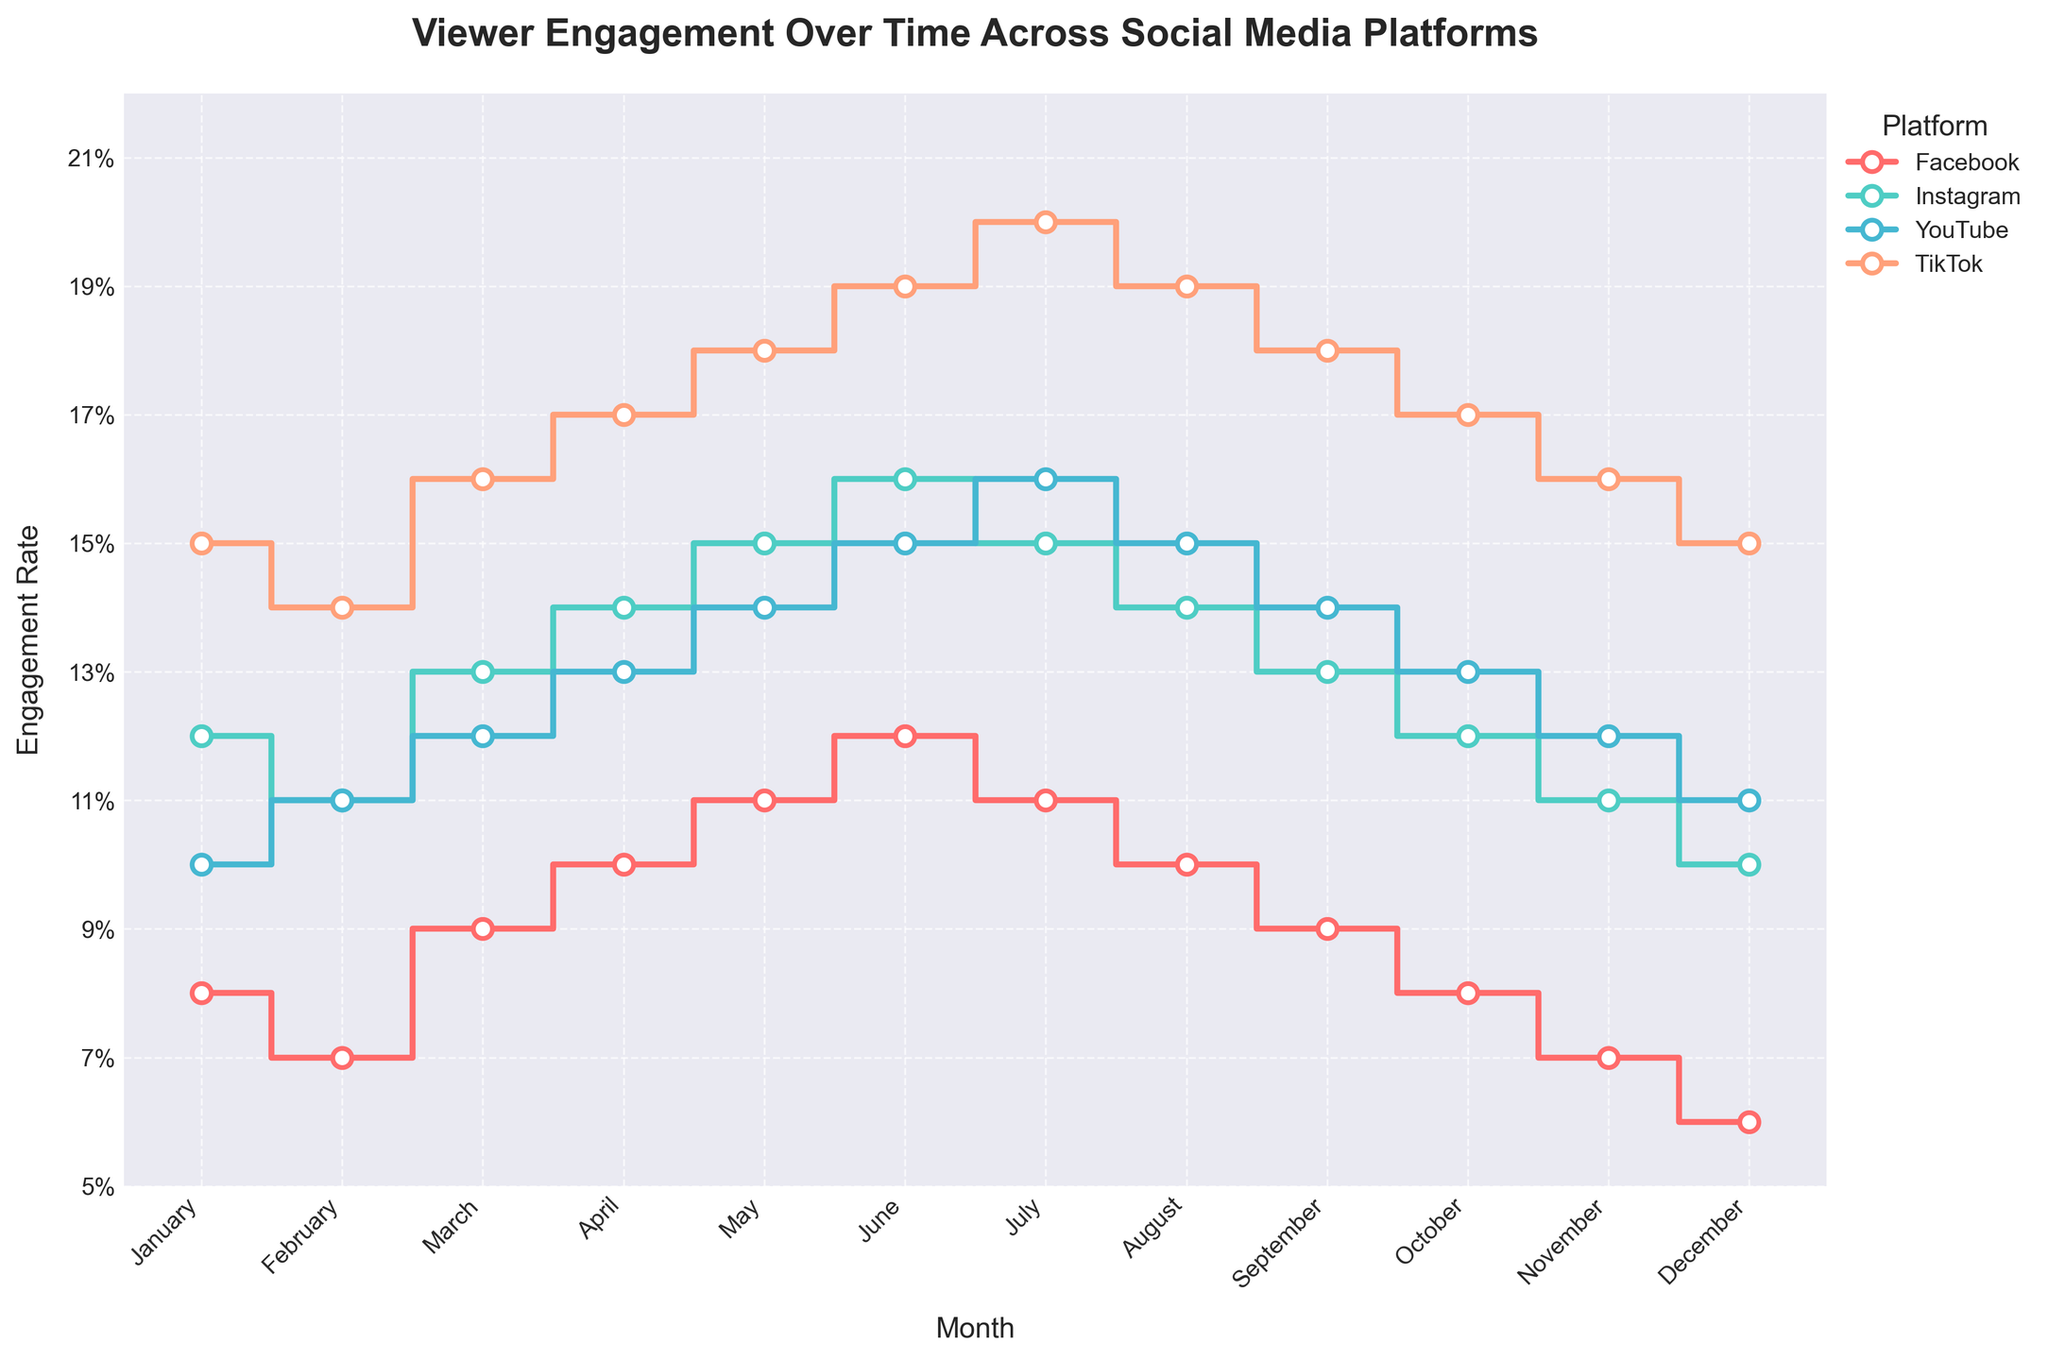What is the title of the plot? The title of the plot is typically located at the top center of the figure. From the given code, we see it is set in a bold font with a size of 16.
Answer: Viewer Engagement Over Time Across Social Media Platforms What month had the highest engagement rate on TikTok? To determine this, look at the TikTok stair plot line and find the highest point on the y-axis, then correlate it with the month on the x-axis.
Answer: July Which platform had the highest engagement rate in January? Compare the engagement rates for January across all platforms by looking at their respective points on the plot.
Answer: TikTok How does the engagement rate on Facebook change from January to December? Examine the Facebook stair plot line from January to December and note the trend of the data points. It starts at the highest value in January and decreases gradually towards December.
Answer: Decreases What is the average engagement rate on YouTube for the year? First, sum the monthly engagement rates for YouTube: 0.10 + 0.11 + 0.12 + 0.13 + 0.14 + 0.15 + 0.16 + 0.15 + 0.14 + 0.13 + 0.12 + 0.11. Then, divide by 12 to find the average. (1.76 / 12 = 0.1467)
Answer: 0.1467 In which month did Instagram and Facebook have the same engagement rate? Look for the points where the Instagram and Facebook lines intersect or are closest to each other. They have the same engagement rate of 0.10 in April.
Answer: April Compare the engagement trends of Instagram and TikTok over the months. Look at the general direction of the stair plot lines for Instagram and TikTok. Note that both show an increase in engagement rates towards the middle of the year, but TikTok has higher peaks and a steadier increase.
Answer: Both increase, but TikTok has higher peaks How many different engagement rates does the figure display? Count the unique engagement rates across all the platforms plotted on the graph. There are multiple rates such as 0.08, 0.09, 0.10, etc., but you ideally count the distinct rates.
Answer: 16 Which two platforms have the closest engagement rates in November? Compare the engagement rates of all platforms in November as depicted in the plot. Facebook and Instagram both have an engagement rate of 0.11 and 0.07 respectively.
Answer: Facebook and Instagram What is the engagement rate difference between Instagram and YouTube in June? Look at the June engagement rates for both Instagram and YouTube, which are 0.16 and 0.15 respectively. Subtract YouTube’s rate from Instagram’s rate (0.16 - 0.15).
Answer: 0.01 